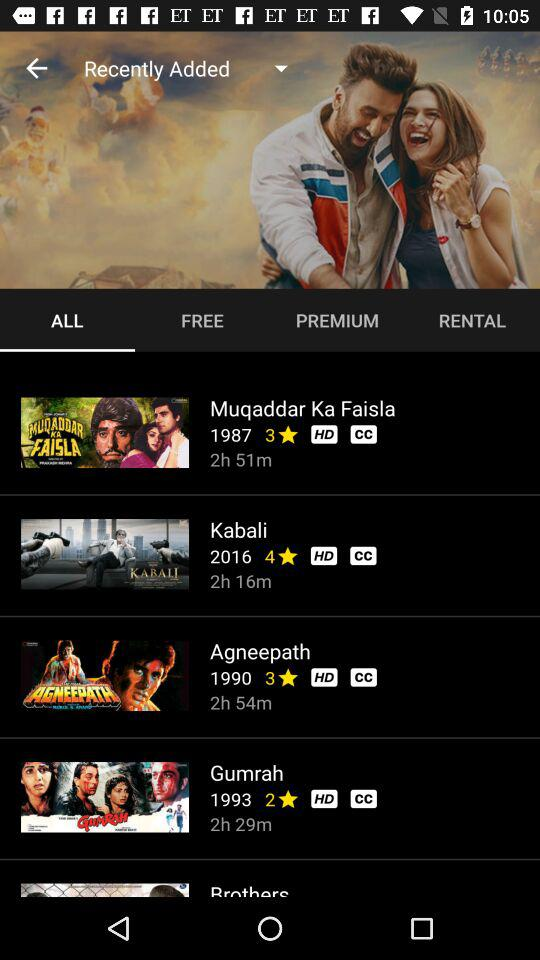Which tab is selected? The selected tab is "ALL". 